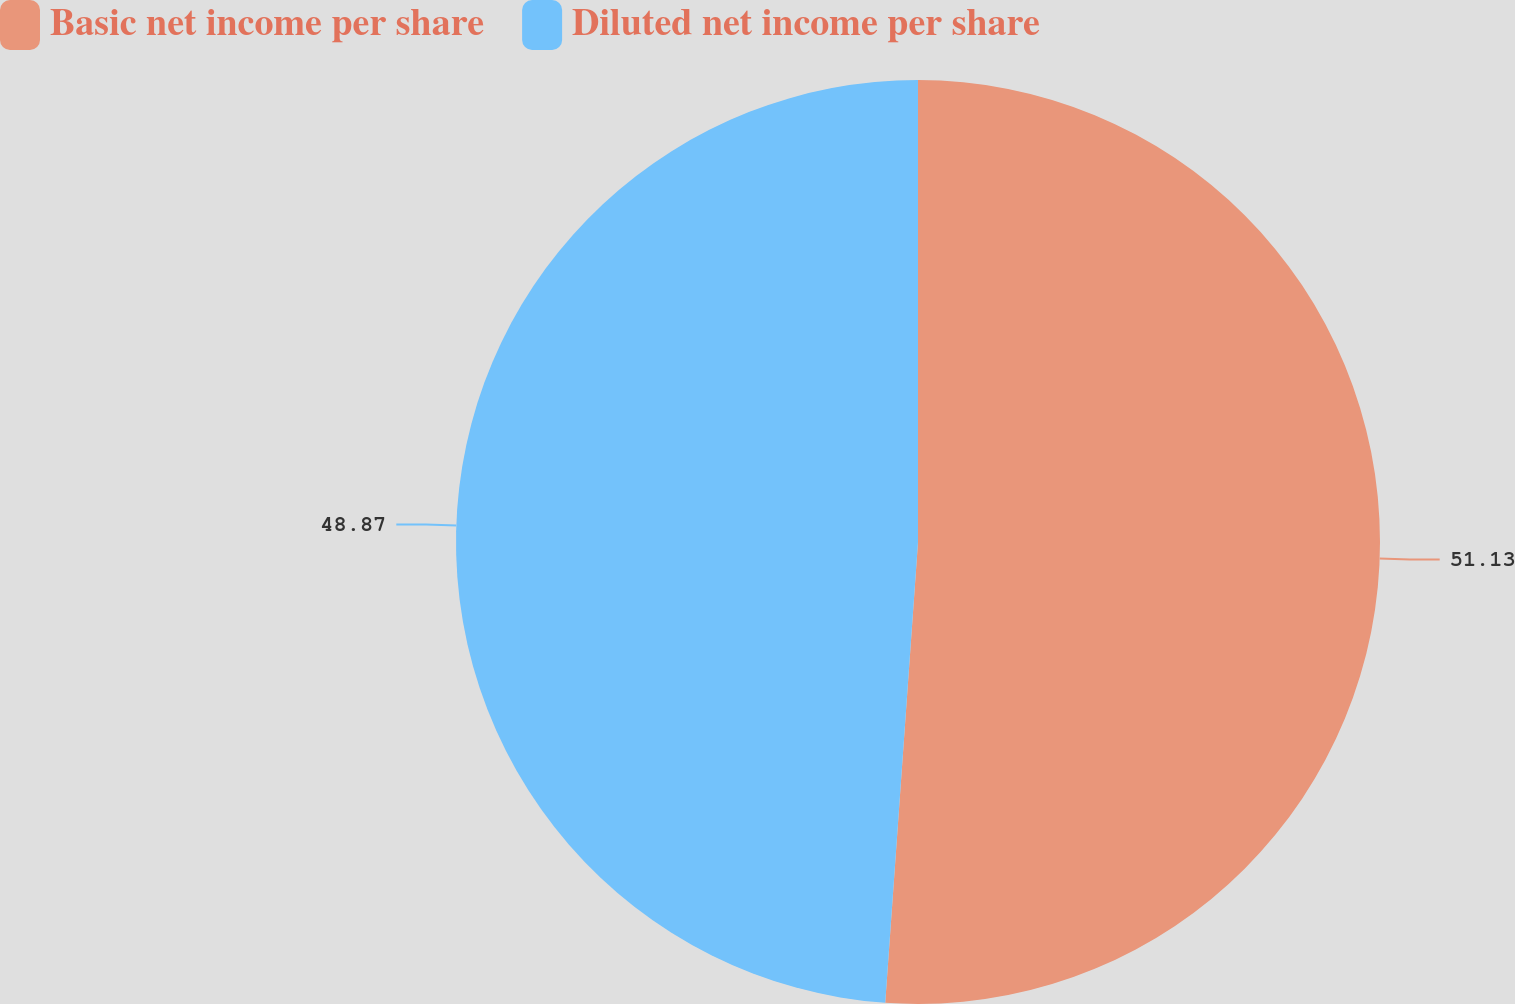<chart> <loc_0><loc_0><loc_500><loc_500><pie_chart><fcel>Basic net income per share<fcel>Diluted net income per share<nl><fcel>51.13%<fcel>48.87%<nl></chart> 